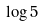<formula> <loc_0><loc_0><loc_500><loc_500>\log 5</formula> 